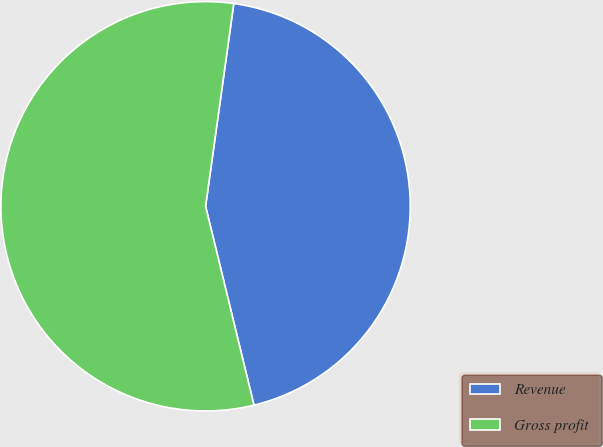<chart> <loc_0><loc_0><loc_500><loc_500><pie_chart><fcel>Revenue<fcel>Gross profit<nl><fcel>44.0%<fcel>56.0%<nl></chart> 